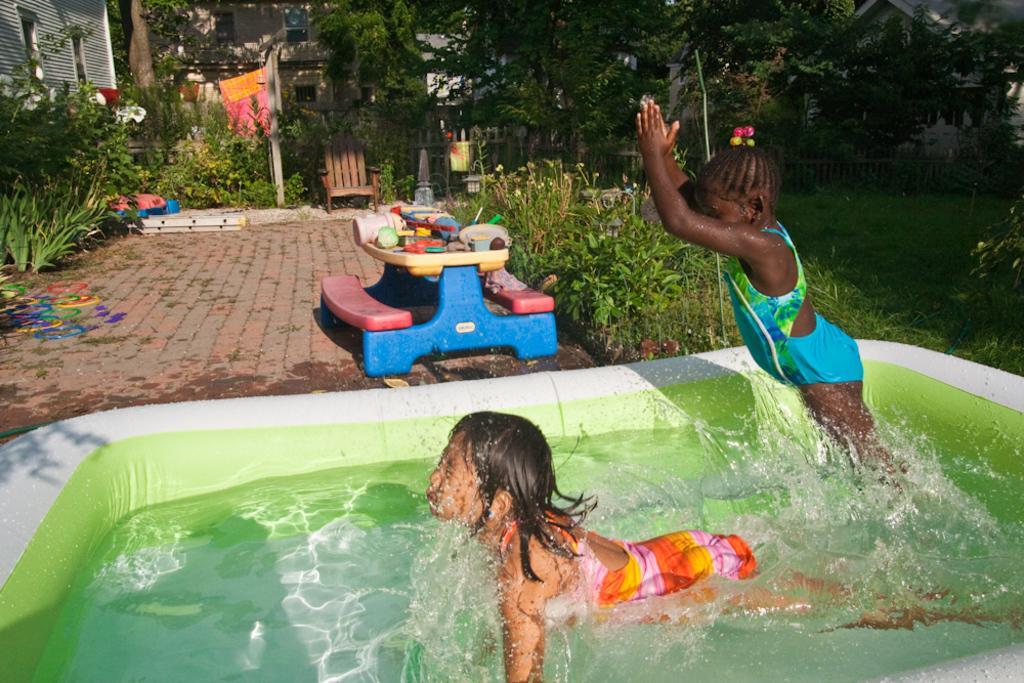Can you describe this image briefly? In this image, we can see two kids, one kid is swimming in the water, there are some green color plants and trees, we can see a floor. 